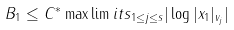Convert formula to latex. <formula><loc_0><loc_0><loc_500><loc_500>B _ { 1 } \leq C ^ { * } \max \lim i t s _ { 1 \leq j \leq s } | \log | x _ { 1 } | _ { v _ { j } } |</formula> 